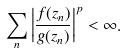Convert formula to latex. <formula><loc_0><loc_0><loc_500><loc_500>\sum _ { n } \left | \frac { f ( z _ { n } ) } { g ( z _ { n } ) } \right | ^ { p } < \infty .</formula> 